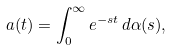Convert formula to latex. <formula><loc_0><loc_0><loc_500><loc_500>a ( t ) = \int _ { 0 } ^ { \infty } e ^ { - s t } \, d \alpha ( s ) ,</formula> 